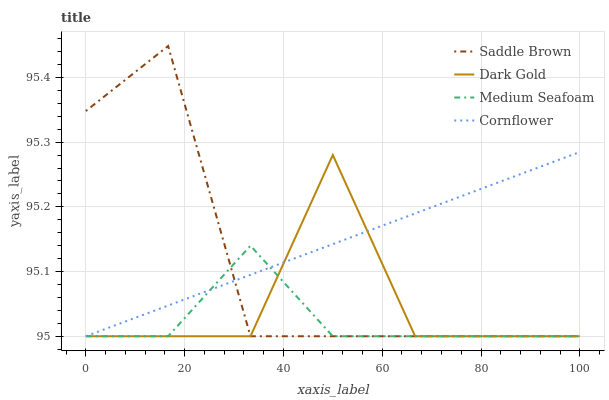Does Medium Seafoam have the minimum area under the curve?
Answer yes or no. Yes. Does Cornflower have the maximum area under the curve?
Answer yes or no. Yes. Does Saddle Brown have the minimum area under the curve?
Answer yes or no. No. Does Saddle Brown have the maximum area under the curve?
Answer yes or no. No. Is Cornflower the smoothest?
Answer yes or no. Yes. Is Dark Gold the roughest?
Answer yes or no. Yes. Is Medium Seafoam the smoothest?
Answer yes or no. No. Is Medium Seafoam the roughest?
Answer yes or no. No. Does Cornflower have the lowest value?
Answer yes or no. Yes. Does Saddle Brown have the highest value?
Answer yes or no. Yes. Does Medium Seafoam have the highest value?
Answer yes or no. No. Does Dark Gold intersect Cornflower?
Answer yes or no. Yes. Is Dark Gold less than Cornflower?
Answer yes or no. No. Is Dark Gold greater than Cornflower?
Answer yes or no. No. 